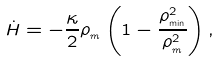Convert formula to latex. <formula><loc_0><loc_0><loc_500><loc_500>\dot { H } = - \frac { \kappa } { 2 } \rho _ { _ { m } } \left ( 1 - \frac { \rho _ { _ { \min } } ^ { 2 } } { \rho _ { _ { m } } ^ { 2 } } \right ) ,</formula> 